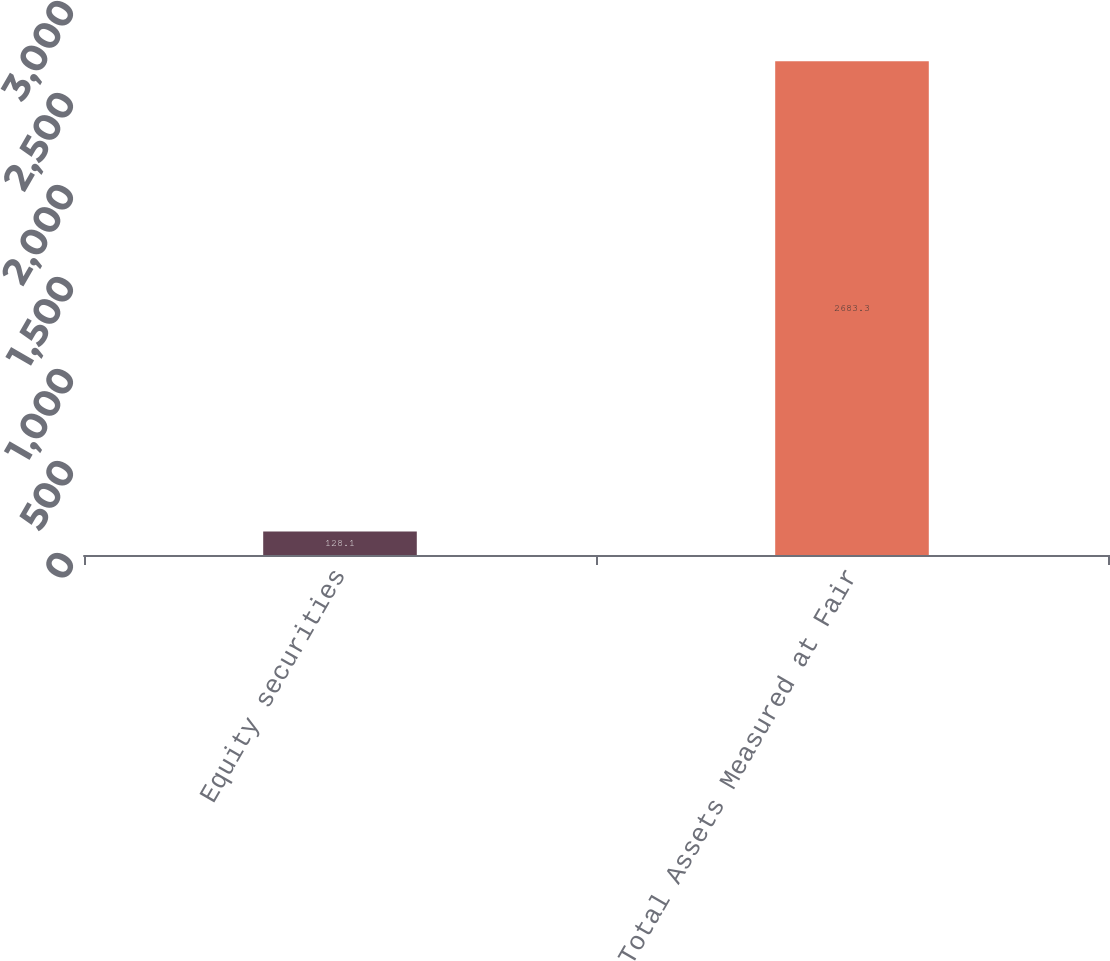Convert chart to OTSL. <chart><loc_0><loc_0><loc_500><loc_500><bar_chart><fcel>Equity securities<fcel>Total Assets Measured at Fair<nl><fcel>128.1<fcel>2683.3<nl></chart> 